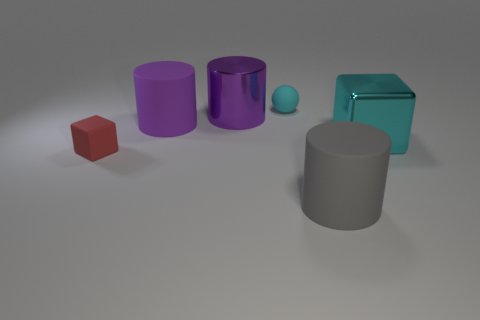What is the shape of the matte thing that is right of the shiny cylinder and left of the large gray cylinder?
Your answer should be very brief. Sphere. What number of tiny cyan cylinders are the same material as the red block?
Provide a short and direct response. 0. Are there fewer large cyan objects that are behind the cyan matte ball than cyan matte things?
Offer a very short reply. Yes. There is a large cylinder that is in front of the large metallic cube; are there any large objects to the right of it?
Provide a short and direct response. Yes. Is there anything else that is the same shape as the gray matte object?
Keep it short and to the point. Yes. Is the cyan metal block the same size as the cyan matte ball?
Make the answer very short. No. There is a purple object in front of the purple cylinder that is right of the rubber cylinder behind the red cube; what is it made of?
Ensure brevity in your answer.  Rubber. Are there the same number of cyan balls that are in front of the purple rubber object and gray things?
Offer a very short reply. No. Is there any other thing that has the same size as the rubber sphere?
Keep it short and to the point. Yes. What number of things are gray matte cubes or large cyan things?
Offer a very short reply. 1. 